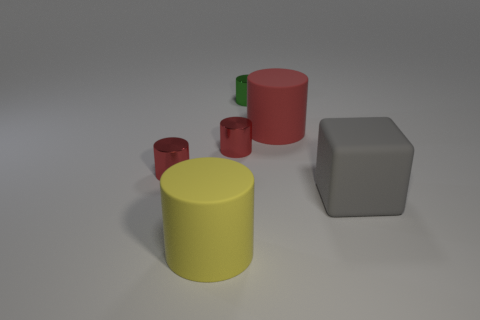Are any small red things visible?
Offer a terse response. Yes. There is a large matte thing that is behind the gray matte block; is it the same shape as the tiny red metallic object that is to the left of the yellow thing?
Ensure brevity in your answer.  Yes. How many large things are red metallic cylinders or brown balls?
Your answer should be compact. 0. The large yellow object that is made of the same material as the large gray block is what shape?
Provide a succinct answer. Cylinder. Do the small green thing and the big gray object have the same shape?
Provide a short and direct response. No. What color is the cube?
Your response must be concise. Gray. What number of things are small cylinders or large spheres?
Ensure brevity in your answer.  3. Is there anything else that is made of the same material as the yellow cylinder?
Your response must be concise. Yes. Is the number of yellow rubber things in front of the large yellow thing less than the number of metal cylinders?
Make the answer very short. Yes. Is the number of green metallic cylinders behind the green cylinder greater than the number of big gray rubber cubes to the right of the yellow rubber cylinder?
Offer a very short reply. No. 